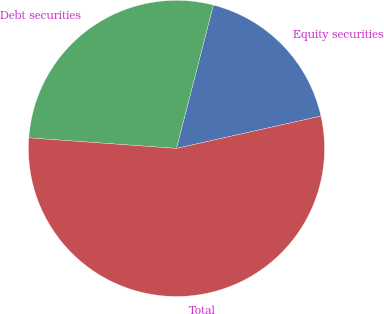Convert chart to OTSL. <chart><loc_0><loc_0><loc_500><loc_500><pie_chart><fcel>Equity securities<fcel>Debt securities<fcel>Total<nl><fcel>17.49%<fcel>27.87%<fcel>54.64%<nl></chart> 